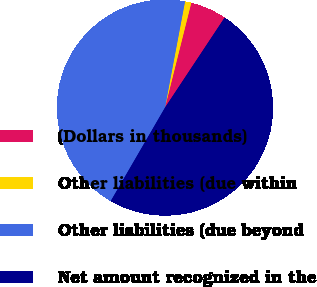Convert chart. <chart><loc_0><loc_0><loc_500><loc_500><pie_chart><fcel>(Dollars in thousands)<fcel>Other liabilities (due within<fcel>Other liabilities (due beyond<fcel>Net amount recognized in the<nl><fcel>5.4%<fcel>0.94%<fcel>44.6%<fcel>49.06%<nl></chart> 